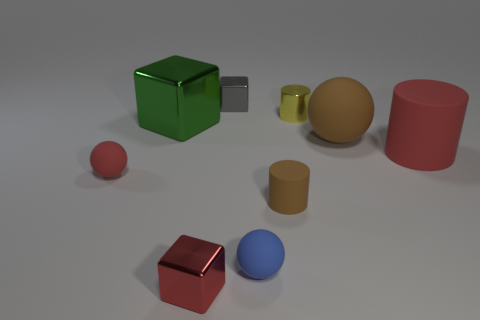Subtract all large spheres. How many spheres are left? 2 Subtract all spheres. How many objects are left? 6 Subtract 1 cubes. How many cubes are left? 2 Subtract 0 purple blocks. How many objects are left? 9 Subtract all yellow cylinders. Subtract all purple blocks. How many cylinders are left? 2 Subtract all purple balls. How many purple cubes are left? 0 Subtract all big red matte things. Subtract all red shiny blocks. How many objects are left? 7 Add 8 tiny yellow things. How many tiny yellow things are left? 9 Add 7 big green blocks. How many big green blocks exist? 8 